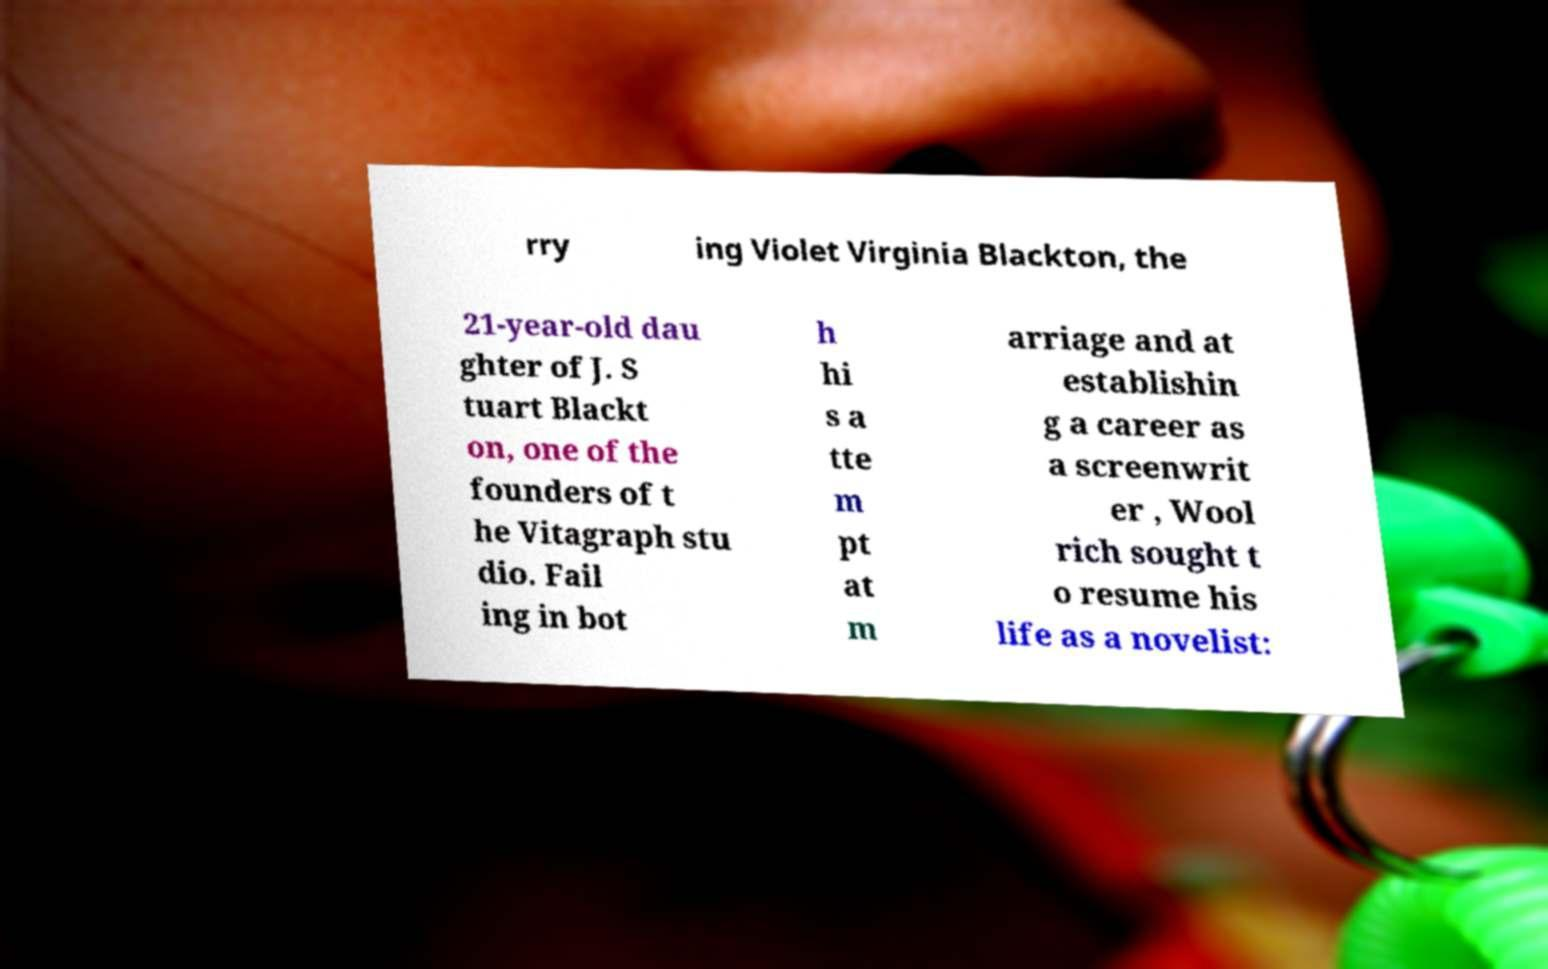There's text embedded in this image that I need extracted. Can you transcribe it verbatim? rry ing Violet Virginia Blackton, the 21-year-old dau ghter of J. S tuart Blackt on, one of the founders of t he Vitagraph stu dio. Fail ing in bot h hi s a tte m pt at m arriage and at establishin g a career as a screenwrit er , Wool rich sought t o resume his life as a novelist: 